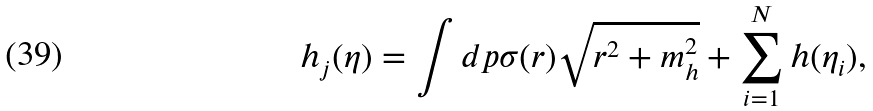<formula> <loc_0><loc_0><loc_500><loc_500>h _ { j } ( \eta ) = \int d p \sigma ( r ) \sqrt { r ^ { 2 } + m _ { h } ^ { 2 } } + \sum ^ { N } _ { i = 1 } h ( \eta _ { i } ) ,</formula> 